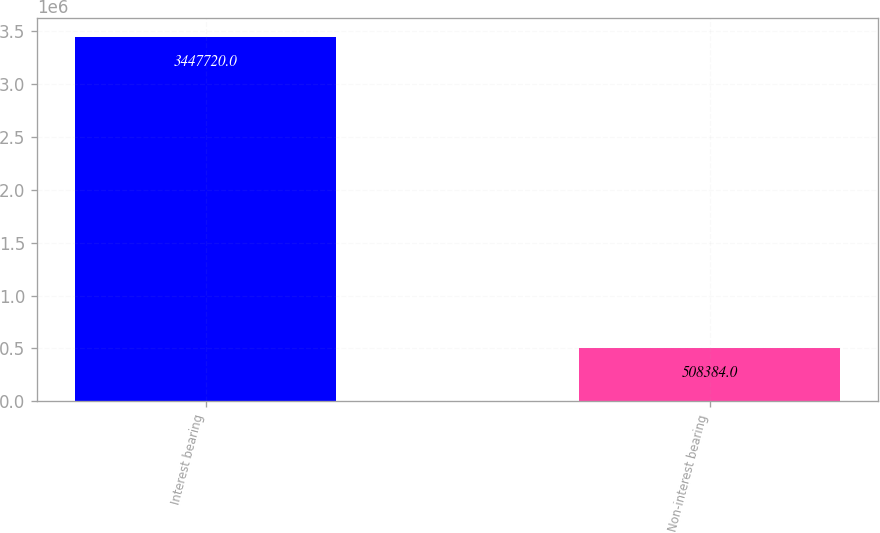Convert chart to OTSL. <chart><loc_0><loc_0><loc_500><loc_500><bar_chart><fcel>Interest bearing<fcel>Non-interest bearing<nl><fcel>3.44772e+06<fcel>508384<nl></chart> 